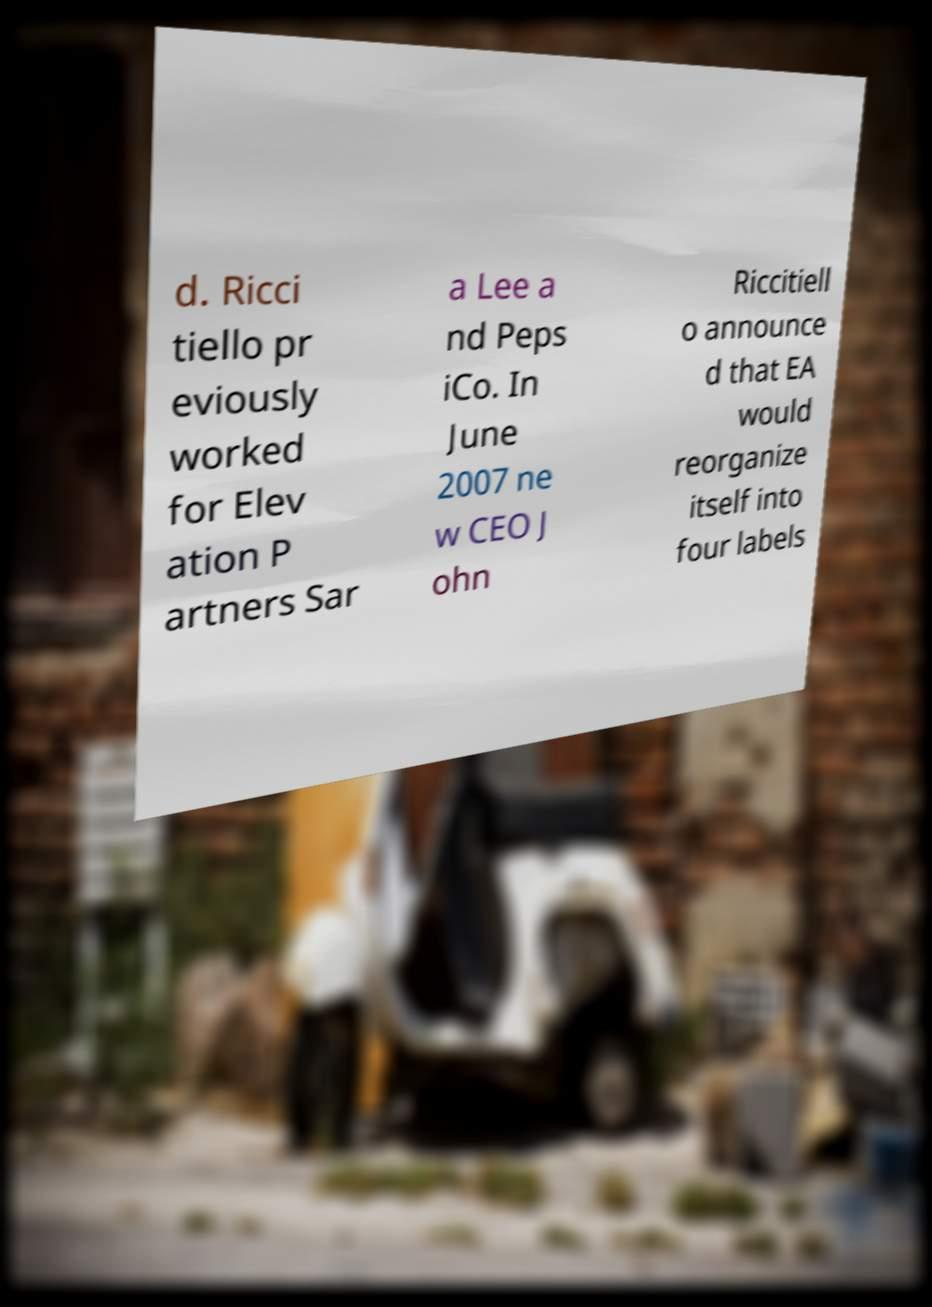Please identify and transcribe the text found in this image. d. Ricci tiello pr eviously worked for Elev ation P artners Sar a Lee a nd Peps iCo. In June 2007 ne w CEO J ohn Riccitiell o announce d that EA would reorganize itself into four labels 